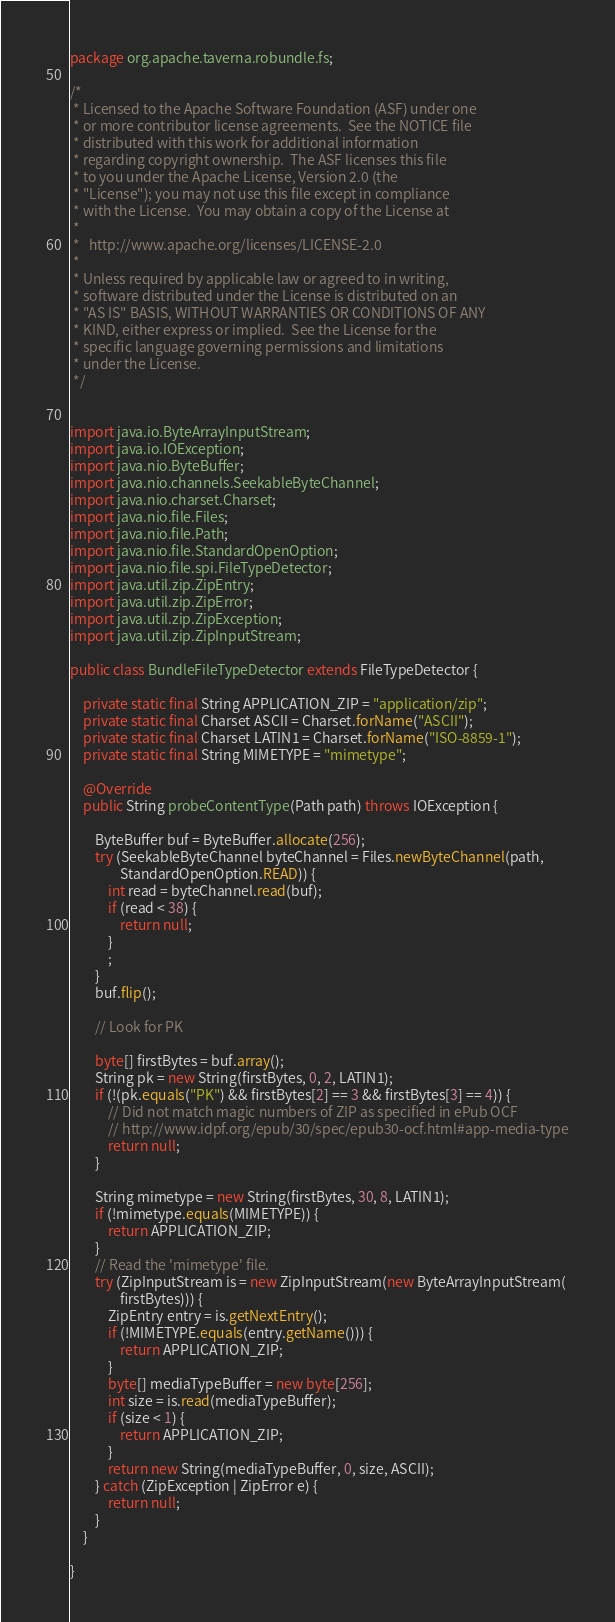Convert code to text. <code><loc_0><loc_0><loc_500><loc_500><_Java_>package org.apache.taverna.robundle.fs;

/*
 * Licensed to the Apache Software Foundation (ASF) under one
 * or more contributor license agreements.  See the NOTICE file
 * distributed with this work for additional information
 * regarding copyright ownership.  The ASF licenses this file
 * to you under the Apache License, Version 2.0 (the
 * "License"); you may not use this file except in compliance
 * with the License.  You may obtain a copy of the License at
 * 
 *   http://www.apache.org/licenses/LICENSE-2.0
 * 
 * Unless required by applicable law or agreed to in writing,
 * software distributed under the License is distributed on an
 * "AS IS" BASIS, WITHOUT WARRANTIES OR CONDITIONS OF ANY
 * KIND, either express or implied.  See the License for the
 * specific language governing permissions and limitations
 * under the License.
 */


import java.io.ByteArrayInputStream;
import java.io.IOException;
import java.nio.ByteBuffer;
import java.nio.channels.SeekableByteChannel;
import java.nio.charset.Charset;
import java.nio.file.Files;
import java.nio.file.Path;
import java.nio.file.StandardOpenOption;
import java.nio.file.spi.FileTypeDetector;
import java.util.zip.ZipEntry;
import java.util.zip.ZipError;
import java.util.zip.ZipException;
import java.util.zip.ZipInputStream;

public class BundleFileTypeDetector extends FileTypeDetector {

	private static final String APPLICATION_ZIP = "application/zip";
	private static final Charset ASCII = Charset.forName("ASCII");
	private static final Charset LATIN1 = Charset.forName("ISO-8859-1");
	private static final String MIMETYPE = "mimetype";

	@Override
	public String probeContentType(Path path) throws IOException {

		ByteBuffer buf = ByteBuffer.allocate(256);
		try (SeekableByteChannel byteChannel = Files.newByteChannel(path,
				StandardOpenOption.READ)) {
			int read = byteChannel.read(buf);
			if (read < 38) {
				return null;
			}
			;
		}
		buf.flip();

		// Look for PK

		byte[] firstBytes = buf.array();
		String pk = new String(firstBytes, 0, 2, LATIN1);
		if (!(pk.equals("PK") && firstBytes[2] == 3 && firstBytes[3] == 4)) {
			// Did not match magic numbers of ZIP as specified in ePub OCF
			// http://www.idpf.org/epub/30/spec/epub30-ocf.html#app-media-type
			return null;
		}

		String mimetype = new String(firstBytes, 30, 8, LATIN1);
		if (!mimetype.equals(MIMETYPE)) {
			return APPLICATION_ZIP;
		}
		// Read the 'mimetype' file.
		try (ZipInputStream is = new ZipInputStream(new ByteArrayInputStream(
				firstBytes))) {
			ZipEntry entry = is.getNextEntry();
			if (!MIMETYPE.equals(entry.getName())) {
				return APPLICATION_ZIP;
			}
			byte[] mediaTypeBuffer = new byte[256];
			int size = is.read(mediaTypeBuffer);
			if (size < 1) {
				return APPLICATION_ZIP;
			}
			return new String(mediaTypeBuffer, 0, size, ASCII);
		} catch (ZipException | ZipError e) {
			return null;
		}
	}

}
</code> 